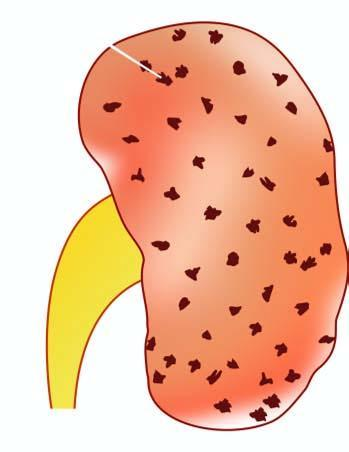what shows characteristic 'flea bitten kidney ' due to tiny petechial haemorrhages on the surface?
Answer the question using a single word or phrase. Cortex 